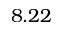<formula> <loc_0><loc_0><loc_500><loc_500>8 . 2 2</formula> 